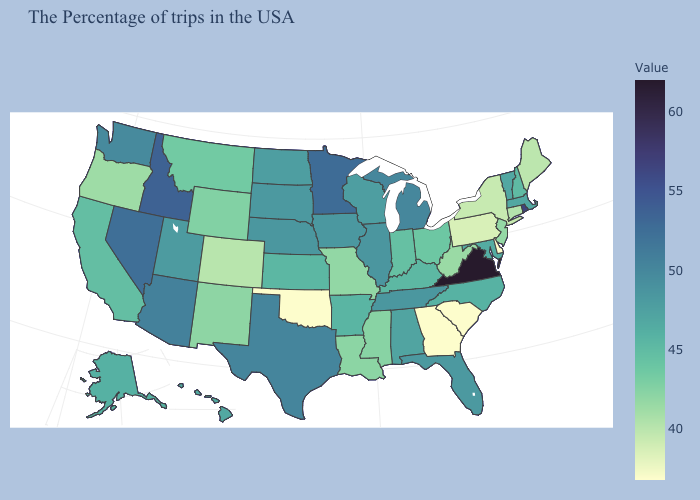Does Missouri have a lower value than North Dakota?
Concise answer only. Yes. Which states have the highest value in the USA?
Answer briefly. Virginia. Does Iowa have the highest value in the MidWest?
Short answer required. No. 